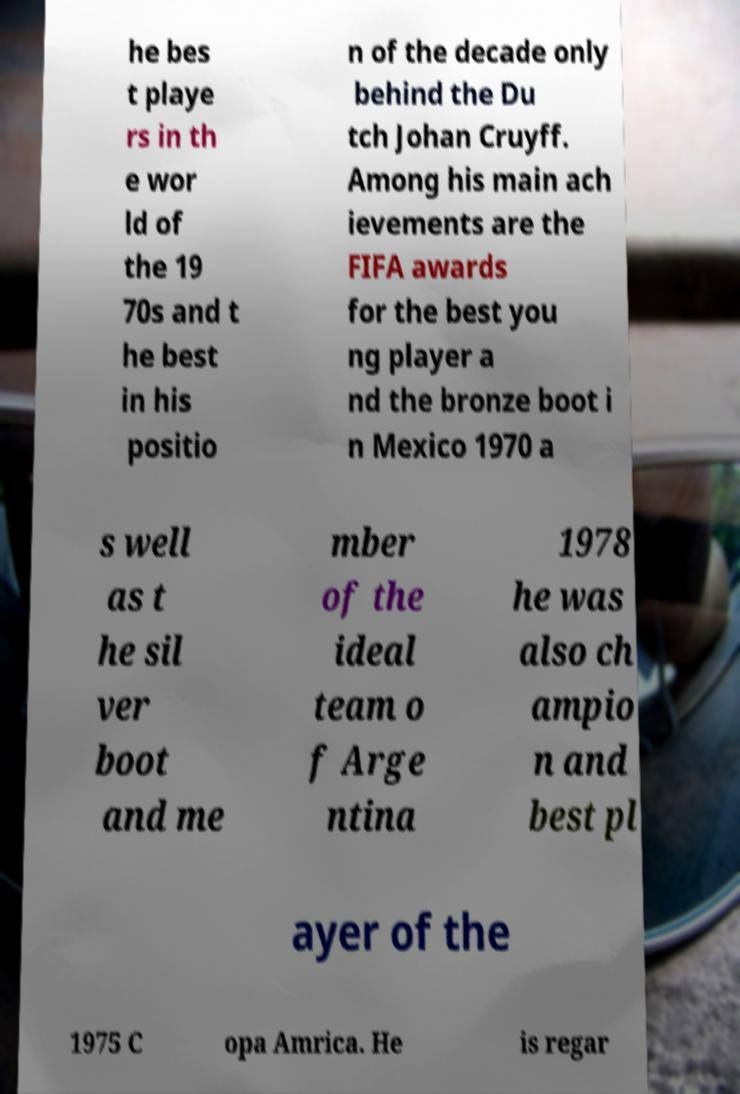There's text embedded in this image that I need extracted. Can you transcribe it verbatim? he bes t playe rs in th e wor ld of the 19 70s and t he best in his positio n of the decade only behind the Du tch Johan Cruyff. Among his main ach ievements are the FIFA awards for the best you ng player a nd the bronze boot i n Mexico 1970 a s well as t he sil ver boot and me mber of the ideal team o f Arge ntina 1978 he was also ch ampio n and best pl ayer of the 1975 C opa Amrica. He is regar 